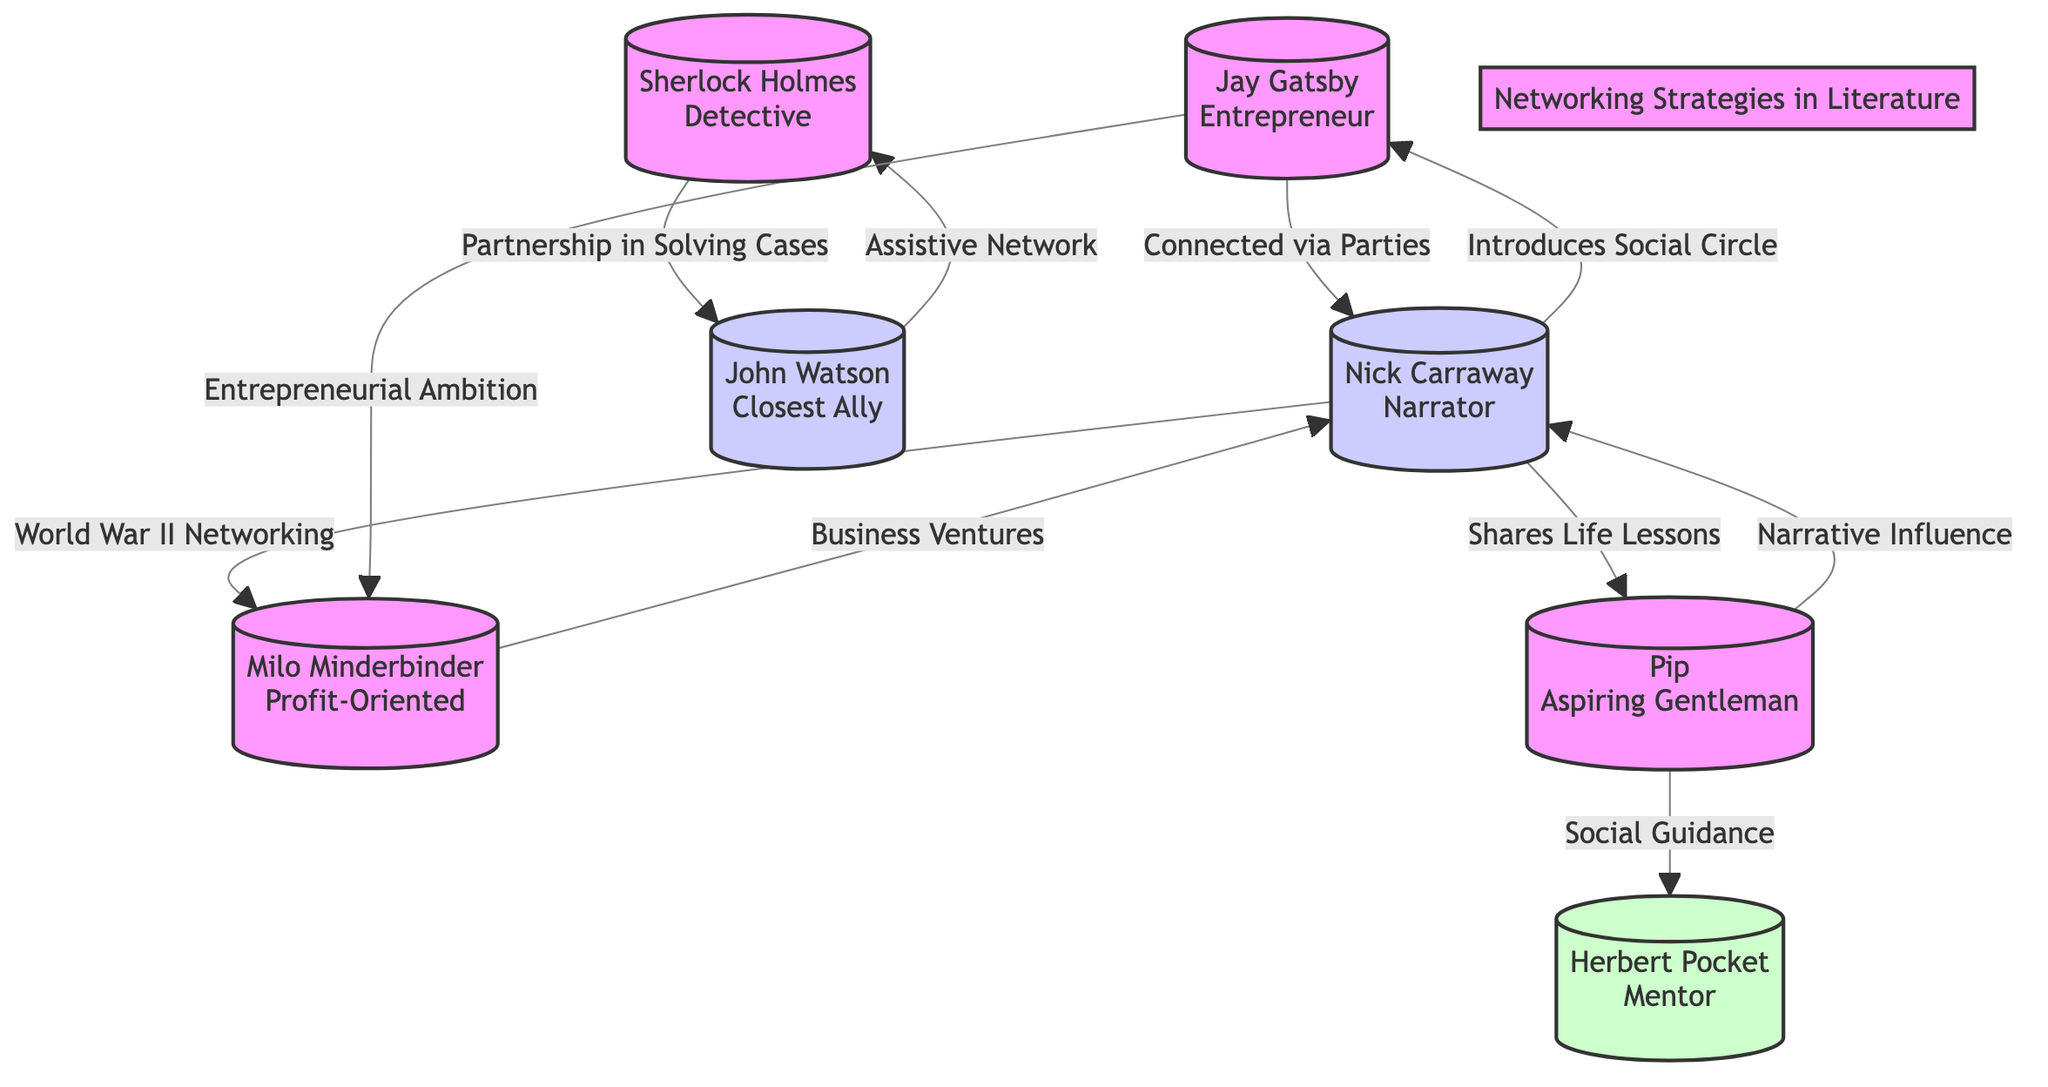What is the central node in the diagram? The central node in the diagram is Nick Carraway, as it connects multiple characters and networking strategies, showing its role as the narrator and social connector.
Answer: Nick Carraway How many nodes are there in total? By counting each character displayed in the diagram, there are seven distinct nodes representing different literary figures.
Answer: 7 What is the connection between Jay Gatsby and Nick Carraway? Jay Gatsby is connected to Nick Carraway via "Connected via Parties," indicating their relationship revolves around Gatsby's social gatherings that Carraway attends.
Answer: Connected via Parties Who does Pip receive social guidance from? The connection shows that Pip receives social guidance from Herbert Pocket, indicating a mentor-mentee relationship where Pocket helps Pip navigate social complexities.
Answer: Herbert Pocket Which two characters are described as having a partnership in solving cases? The diagram indicates that Sherlock Holmes and John Watson are connected through "Partnership in Solving Cases," highlighting their collaborative efforts in detective work.
Answer: Sherlock Holmes and John Watson What type of networking strategy does Milo Minderbinder primarily engage in? Milo Minderbinder is classified as "Profit-Oriented," indicating that his networking strategies revolve around business ventures aimed at generating profit, as shown in the diagram.
Answer: Profit-Oriented Which character influences Nick Carraway's narrative? The diagram demonstrates that Pip influences Nick Carraway's narrative through a connection labeled "Narrative Influence," suggesting that Pip's experiences shape Carraway's storytelling.
Answer: Pip How many edges connect to Nick Carraway? By examining the connections, there are four edges leading to Nick Carraway, showcasing his central role in the networking strategies depicted in the diagram.
Answer: 4 What is the relationship between Jay Gatsby and Milo Minderbinder? The connection between Jay Gatsby and Milo Minderbinder is characterized by "Entrepreneurial Ambition," illustrating how Gatsby's ambitions may intersect with business strategies associated with Minderbinder.
Answer: Entrepreneurial Ambition 